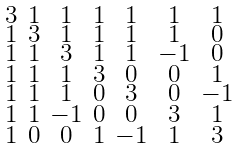<formula> <loc_0><loc_0><loc_500><loc_500>\begin{smallmatrix} 3 & 1 & 1 & 1 & 1 & 1 & 1 \\ 1 & 3 & 1 & 1 & 1 & 1 & 0 \\ 1 & 1 & 3 & 1 & 1 & - 1 & 0 \\ 1 & 1 & 1 & 3 & 0 & 0 & 1 \\ 1 & 1 & 1 & 0 & 3 & 0 & - 1 \\ 1 & 1 & - 1 & 0 & 0 & 3 & 1 \\ 1 & 0 & 0 & 1 & - 1 & 1 & 3 \end{smallmatrix}</formula> 